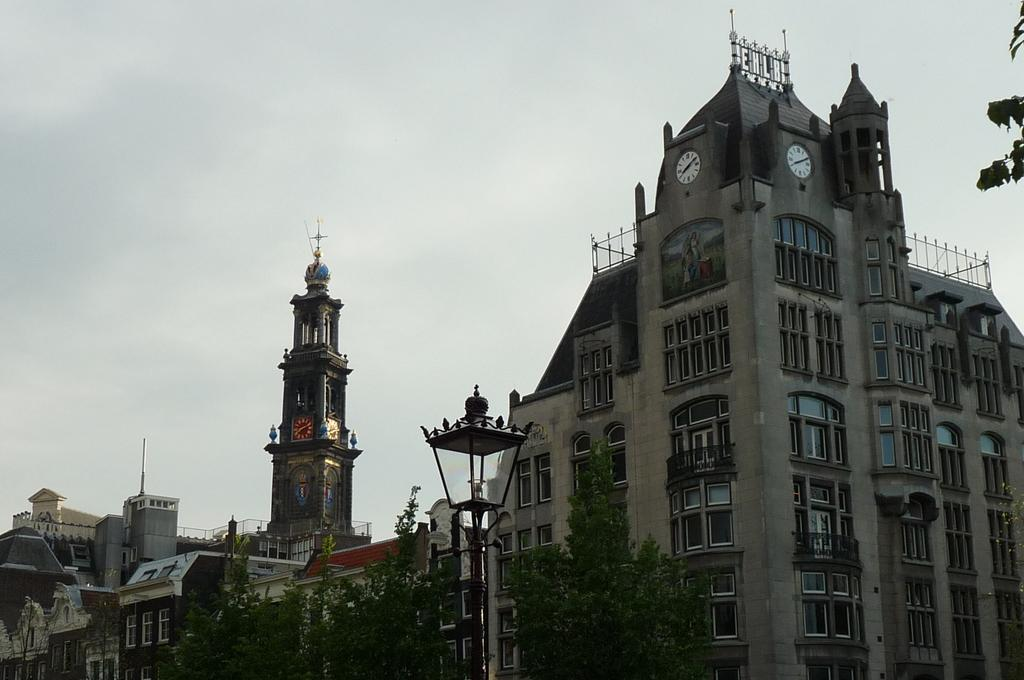What type of structures can be seen in the image? There are buildings in the image. What objects are present that indicate the time? There are clocks in the image. What type of vegetation is visible in the image? There are trees in the image. What type of lighting is present in the image? There is a street lamp in the image. What is visible at the top of the image? The sky is visible at the top of the image. Can you see a thumbprint on the street lamp in the image? There is no thumbprint or any reference to a thumb in the image. Is there a ring around the sun in the sky? The image does not show the sun, only the sky, so it is not possible to determine if there is a ring around the sun. 